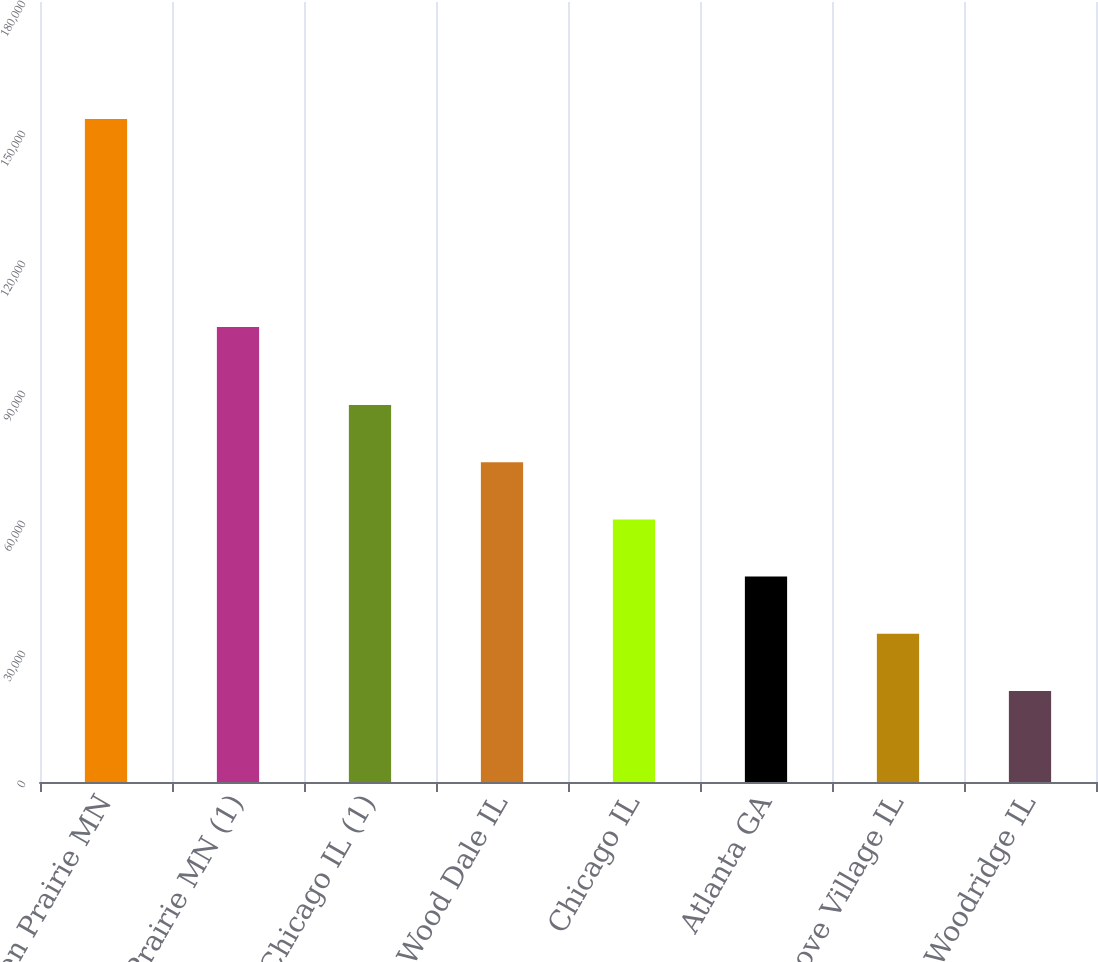Convert chart to OTSL. <chart><loc_0><loc_0><loc_500><loc_500><bar_chart><fcel>Eden Prairie MN<fcel>Eden Prairie MN (1)<fcel>Chicago IL (1)<fcel>Wood Dale IL<fcel>Chicago IL<fcel>Atlanta GA<fcel>Elk Grove Village IL<fcel>Woodridge IL<nl><fcel>153000<fcel>105000<fcel>87000<fcel>73800<fcel>60600<fcel>47400<fcel>34200<fcel>21000<nl></chart> 